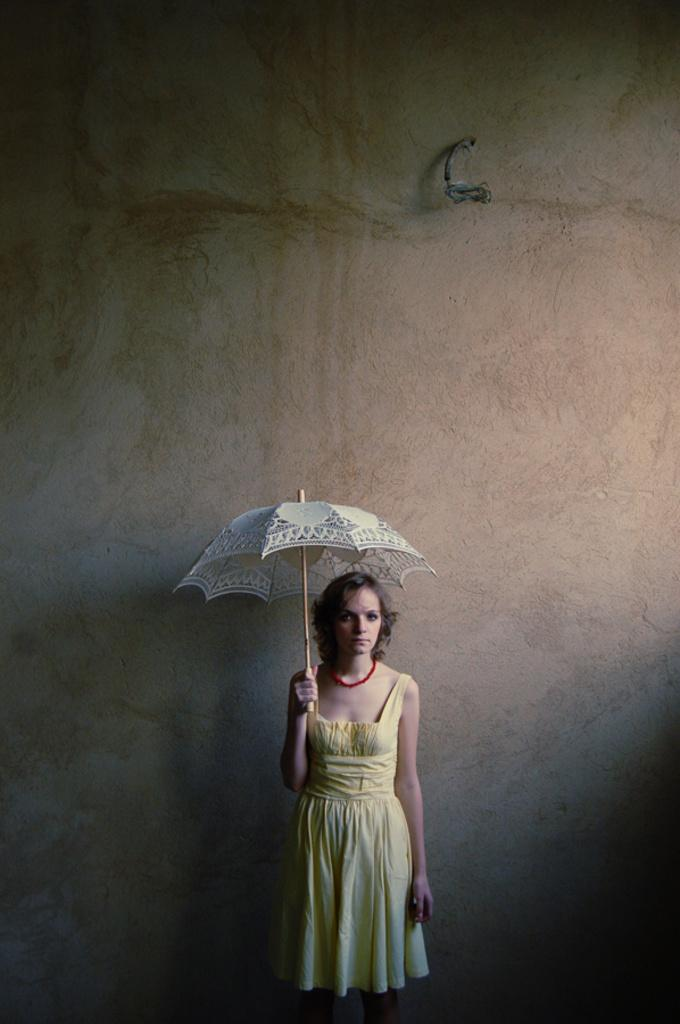Who or what is present in the image? There is a person in the image. What is the person wearing? The person is wearing a yellow dress. What object is the person holding? The person is holding an umbrella. What can be seen in the background of the image? There is a wall visible in the image. What type of oatmeal is being prepared in the image? There is no oatmeal present in the image, and therefore no such activity can be observed. 